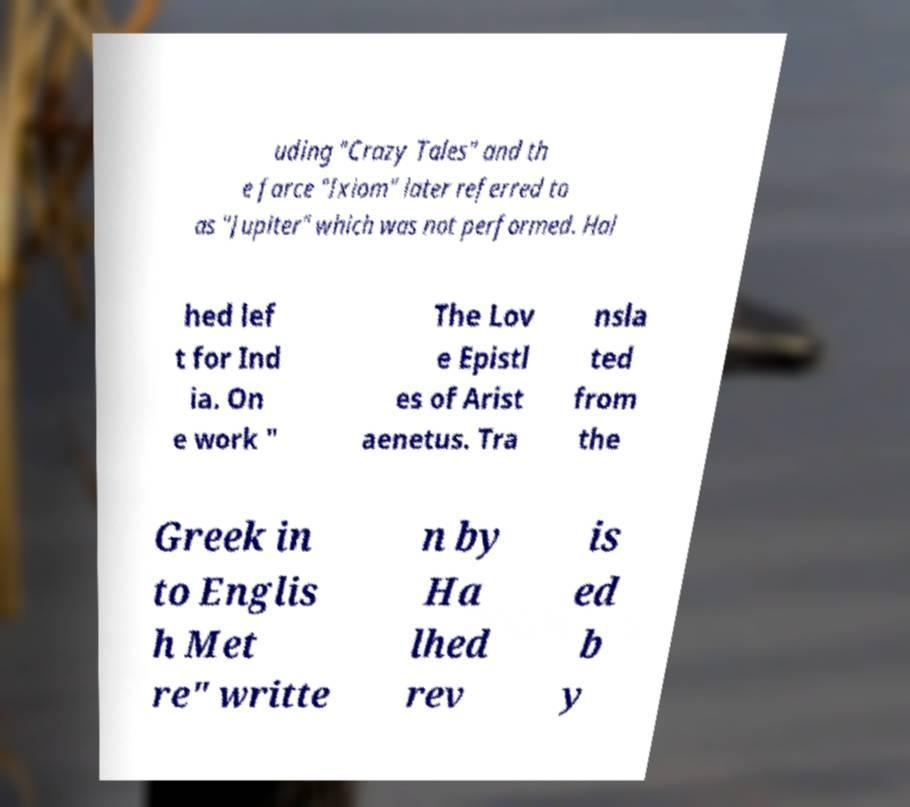There's text embedded in this image that I need extracted. Can you transcribe it verbatim? uding "Crazy Tales" and th e farce "Ixiom" later referred to as "Jupiter" which was not performed. Hal hed lef t for Ind ia. On e work " The Lov e Epistl es of Arist aenetus. Tra nsla ted from the Greek in to Englis h Met re" writte n by Ha lhed rev is ed b y 